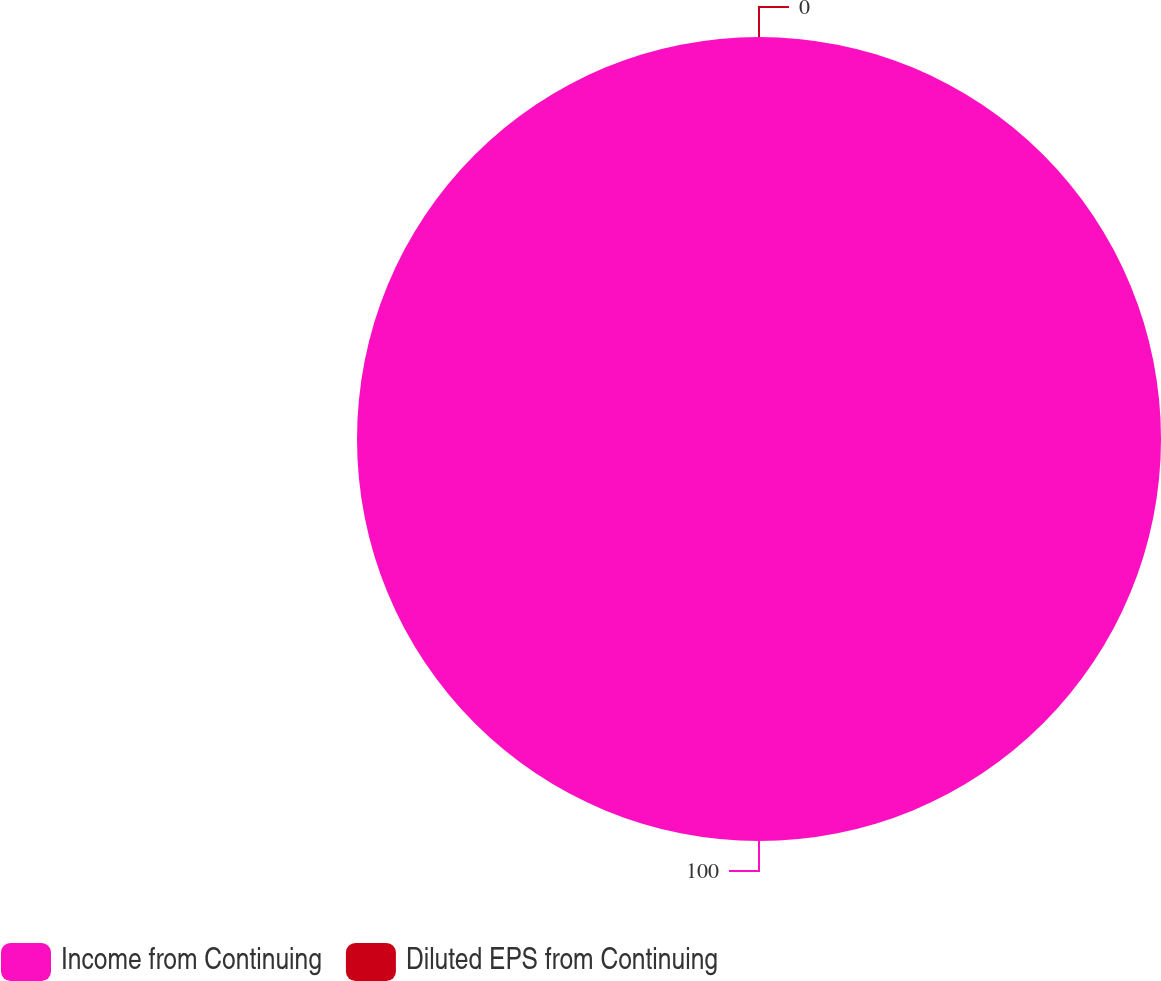Convert chart. <chart><loc_0><loc_0><loc_500><loc_500><pie_chart><fcel>Income from Continuing<fcel>Diluted EPS from Continuing<nl><fcel>100.0%<fcel>0.0%<nl></chart> 